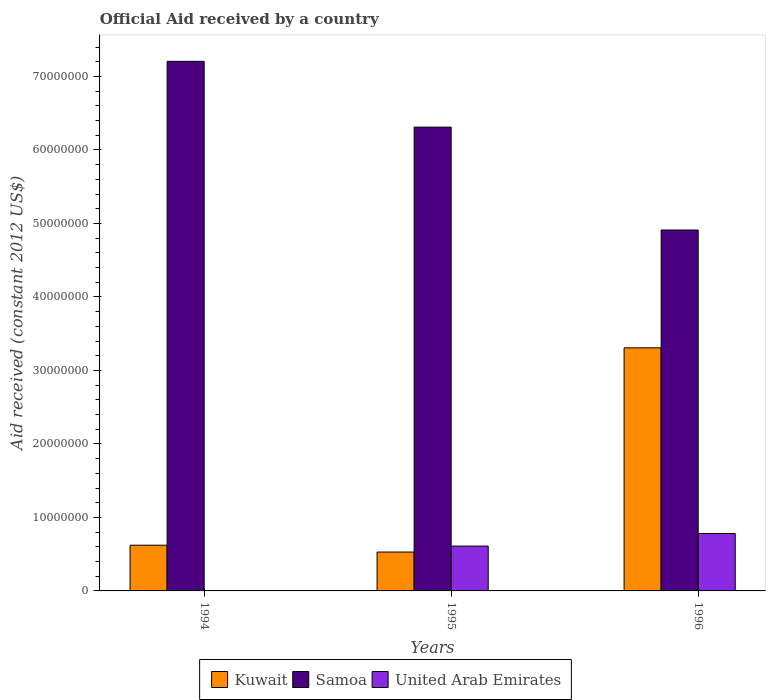How many different coloured bars are there?
Give a very brief answer. 3. How many groups of bars are there?
Provide a short and direct response. 3. How many bars are there on the 2nd tick from the left?
Your answer should be very brief. 3. What is the label of the 1st group of bars from the left?
Give a very brief answer. 1994. In how many cases, is the number of bars for a given year not equal to the number of legend labels?
Your answer should be very brief. 1. What is the net official aid received in Kuwait in 1996?
Offer a very short reply. 3.31e+07. Across all years, what is the maximum net official aid received in Samoa?
Give a very brief answer. 7.21e+07. Across all years, what is the minimum net official aid received in Samoa?
Ensure brevity in your answer.  4.91e+07. What is the total net official aid received in Kuwait in the graph?
Give a very brief answer. 4.46e+07. What is the difference between the net official aid received in Samoa in 1994 and that in 1995?
Keep it short and to the point. 8.95e+06. What is the difference between the net official aid received in Samoa in 1996 and the net official aid received in United Arab Emirates in 1995?
Give a very brief answer. 4.30e+07. What is the average net official aid received in Kuwait per year?
Keep it short and to the point. 1.49e+07. In the year 1995, what is the difference between the net official aid received in Kuwait and net official aid received in United Arab Emirates?
Your answer should be very brief. -8.10e+05. In how many years, is the net official aid received in United Arab Emirates greater than 34000000 US$?
Provide a succinct answer. 0. What is the ratio of the net official aid received in Samoa in 1994 to that in 1996?
Give a very brief answer. 1.47. Is the net official aid received in Kuwait in 1995 less than that in 1996?
Your answer should be compact. Yes. Is the difference between the net official aid received in Kuwait in 1995 and 1996 greater than the difference between the net official aid received in United Arab Emirates in 1995 and 1996?
Your response must be concise. No. What is the difference between the highest and the second highest net official aid received in Kuwait?
Provide a short and direct response. 2.69e+07. What is the difference between the highest and the lowest net official aid received in United Arab Emirates?
Your answer should be compact. 7.81e+06. Is it the case that in every year, the sum of the net official aid received in Kuwait and net official aid received in Samoa is greater than the net official aid received in United Arab Emirates?
Your answer should be very brief. Yes. How many bars are there?
Your response must be concise. 8. Are all the bars in the graph horizontal?
Make the answer very short. No. Are the values on the major ticks of Y-axis written in scientific E-notation?
Make the answer very short. No. Does the graph contain any zero values?
Offer a very short reply. Yes. Does the graph contain grids?
Give a very brief answer. No. What is the title of the graph?
Provide a short and direct response. Official Aid received by a country. What is the label or title of the X-axis?
Your answer should be very brief. Years. What is the label or title of the Y-axis?
Your answer should be very brief. Aid received (constant 2012 US$). What is the Aid received (constant 2012 US$) in Kuwait in 1994?
Provide a succinct answer. 6.22e+06. What is the Aid received (constant 2012 US$) in Samoa in 1994?
Provide a succinct answer. 7.21e+07. What is the Aid received (constant 2012 US$) of Kuwait in 1995?
Offer a very short reply. 5.29e+06. What is the Aid received (constant 2012 US$) of Samoa in 1995?
Give a very brief answer. 6.31e+07. What is the Aid received (constant 2012 US$) in United Arab Emirates in 1995?
Your response must be concise. 6.10e+06. What is the Aid received (constant 2012 US$) in Kuwait in 1996?
Offer a terse response. 3.31e+07. What is the Aid received (constant 2012 US$) of Samoa in 1996?
Your answer should be compact. 4.91e+07. What is the Aid received (constant 2012 US$) of United Arab Emirates in 1996?
Make the answer very short. 7.81e+06. Across all years, what is the maximum Aid received (constant 2012 US$) of Kuwait?
Your response must be concise. 3.31e+07. Across all years, what is the maximum Aid received (constant 2012 US$) in Samoa?
Ensure brevity in your answer.  7.21e+07. Across all years, what is the maximum Aid received (constant 2012 US$) of United Arab Emirates?
Keep it short and to the point. 7.81e+06. Across all years, what is the minimum Aid received (constant 2012 US$) of Kuwait?
Give a very brief answer. 5.29e+06. Across all years, what is the minimum Aid received (constant 2012 US$) in Samoa?
Provide a succinct answer. 4.91e+07. What is the total Aid received (constant 2012 US$) of Kuwait in the graph?
Give a very brief answer. 4.46e+07. What is the total Aid received (constant 2012 US$) of Samoa in the graph?
Ensure brevity in your answer.  1.84e+08. What is the total Aid received (constant 2012 US$) in United Arab Emirates in the graph?
Keep it short and to the point. 1.39e+07. What is the difference between the Aid received (constant 2012 US$) of Kuwait in 1994 and that in 1995?
Provide a short and direct response. 9.30e+05. What is the difference between the Aid received (constant 2012 US$) of Samoa in 1994 and that in 1995?
Keep it short and to the point. 8.95e+06. What is the difference between the Aid received (constant 2012 US$) of Kuwait in 1994 and that in 1996?
Your answer should be compact. -2.69e+07. What is the difference between the Aid received (constant 2012 US$) of Samoa in 1994 and that in 1996?
Offer a terse response. 2.30e+07. What is the difference between the Aid received (constant 2012 US$) in Kuwait in 1995 and that in 1996?
Make the answer very short. -2.78e+07. What is the difference between the Aid received (constant 2012 US$) of Samoa in 1995 and that in 1996?
Offer a very short reply. 1.40e+07. What is the difference between the Aid received (constant 2012 US$) of United Arab Emirates in 1995 and that in 1996?
Your answer should be very brief. -1.71e+06. What is the difference between the Aid received (constant 2012 US$) in Kuwait in 1994 and the Aid received (constant 2012 US$) in Samoa in 1995?
Make the answer very short. -5.69e+07. What is the difference between the Aid received (constant 2012 US$) of Samoa in 1994 and the Aid received (constant 2012 US$) of United Arab Emirates in 1995?
Your response must be concise. 6.60e+07. What is the difference between the Aid received (constant 2012 US$) of Kuwait in 1994 and the Aid received (constant 2012 US$) of Samoa in 1996?
Give a very brief answer. -4.29e+07. What is the difference between the Aid received (constant 2012 US$) of Kuwait in 1994 and the Aid received (constant 2012 US$) of United Arab Emirates in 1996?
Your answer should be compact. -1.59e+06. What is the difference between the Aid received (constant 2012 US$) of Samoa in 1994 and the Aid received (constant 2012 US$) of United Arab Emirates in 1996?
Ensure brevity in your answer.  6.42e+07. What is the difference between the Aid received (constant 2012 US$) of Kuwait in 1995 and the Aid received (constant 2012 US$) of Samoa in 1996?
Offer a terse response. -4.38e+07. What is the difference between the Aid received (constant 2012 US$) in Kuwait in 1995 and the Aid received (constant 2012 US$) in United Arab Emirates in 1996?
Provide a succinct answer. -2.52e+06. What is the difference between the Aid received (constant 2012 US$) in Samoa in 1995 and the Aid received (constant 2012 US$) in United Arab Emirates in 1996?
Offer a terse response. 5.53e+07. What is the average Aid received (constant 2012 US$) in Kuwait per year?
Provide a short and direct response. 1.49e+07. What is the average Aid received (constant 2012 US$) in Samoa per year?
Your answer should be very brief. 6.14e+07. What is the average Aid received (constant 2012 US$) in United Arab Emirates per year?
Offer a terse response. 4.64e+06. In the year 1994, what is the difference between the Aid received (constant 2012 US$) of Kuwait and Aid received (constant 2012 US$) of Samoa?
Your answer should be compact. -6.58e+07. In the year 1995, what is the difference between the Aid received (constant 2012 US$) of Kuwait and Aid received (constant 2012 US$) of Samoa?
Offer a very short reply. -5.78e+07. In the year 1995, what is the difference between the Aid received (constant 2012 US$) in Kuwait and Aid received (constant 2012 US$) in United Arab Emirates?
Your answer should be compact. -8.10e+05. In the year 1995, what is the difference between the Aid received (constant 2012 US$) of Samoa and Aid received (constant 2012 US$) of United Arab Emirates?
Provide a succinct answer. 5.70e+07. In the year 1996, what is the difference between the Aid received (constant 2012 US$) of Kuwait and Aid received (constant 2012 US$) of Samoa?
Your response must be concise. -1.60e+07. In the year 1996, what is the difference between the Aid received (constant 2012 US$) in Kuwait and Aid received (constant 2012 US$) in United Arab Emirates?
Make the answer very short. 2.53e+07. In the year 1996, what is the difference between the Aid received (constant 2012 US$) of Samoa and Aid received (constant 2012 US$) of United Arab Emirates?
Your response must be concise. 4.13e+07. What is the ratio of the Aid received (constant 2012 US$) of Kuwait in 1994 to that in 1995?
Ensure brevity in your answer.  1.18. What is the ratio of the Aid received (constant 2012 US$) of Samoa in 1994 to that in 1995?
Offer a terse response. 1.14. What is the ratio of the Aid received (constant 2012 US$) of Kuwait in 1994 to that in 1996?
Keep it short and to the point. 0.19. What is the ratio of the Aid received (constant 2012 US$) in Samoa in 1994 to that in 1996?
Provide a succinct answer. 1.47. What is the ratio of the Aid received (constant 2012 US$) in Kuwait in 1995 to that in 1996?
Offer a very short reply. 0.16. What is the ratio of the Aid received (constant 2012 US$) in Samoa in 1995 to that in 1996?
Provide a succinct answer. 1.29. What is the ratio of the Aid received (constant 2012 US$) of United Arab Emirates in 1995 to that in 1996?
Your answer should be compact. 0.78. What is the difference between the highest and the second highest Aid received (constant 2012 US$) in Kuwait?
Offer a terse response. 2.69e+07. What is the difference between the highest and the second highest Aid received (constant 2012 US$) of Samoa?
Give a very brief answer. 8.95e+06. What is the difference between the highest and the lowest Aid received (constant 2012 US$) in Kuwait?
Your answer should be very brief. 2.78e+07. What is the difference between the highest and the lowest Aid received (constant 2012 US$) in Samoa?
Offer a very short reply. 2.30e+07. What is the difference between the highest and the lowest Aid received (constant 2012 US$) of United Arab Emirates?
Your answer should be compact. 7.81e+06. 